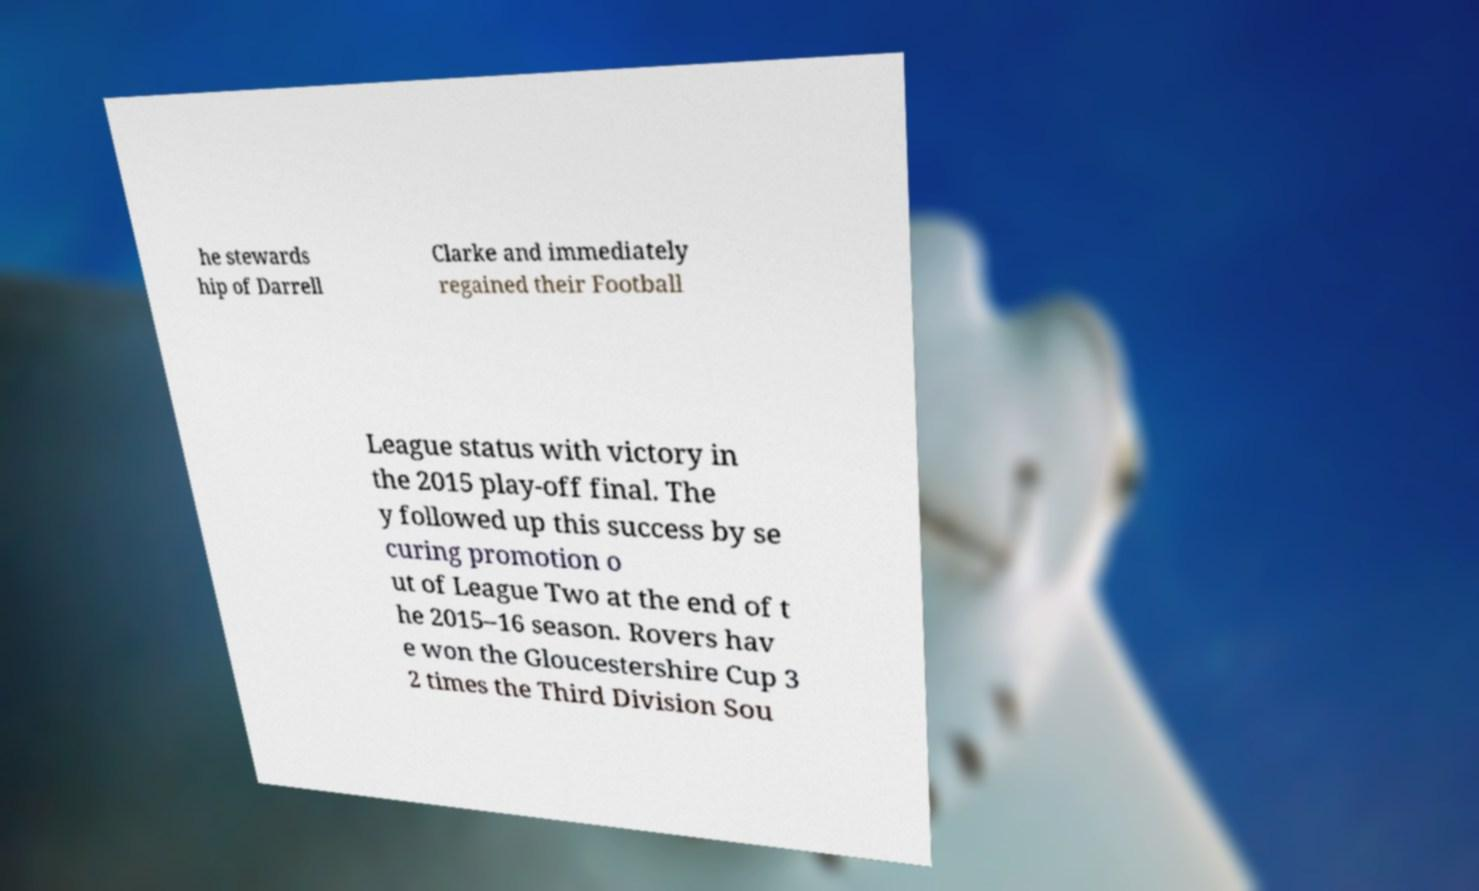For documentation purposes, I need the text within this image transcribed. Could you provide that? he stewards hip of Darrell Clarke and immediately regained their Football League status with victory in the 2015 play-off final. The y followed up this success by se curing promotion o ut of League Two at the end of t he 2015–16 season. Rovers hav e won the Gloucestershire Cup 3 2 times the Third Division Sou 